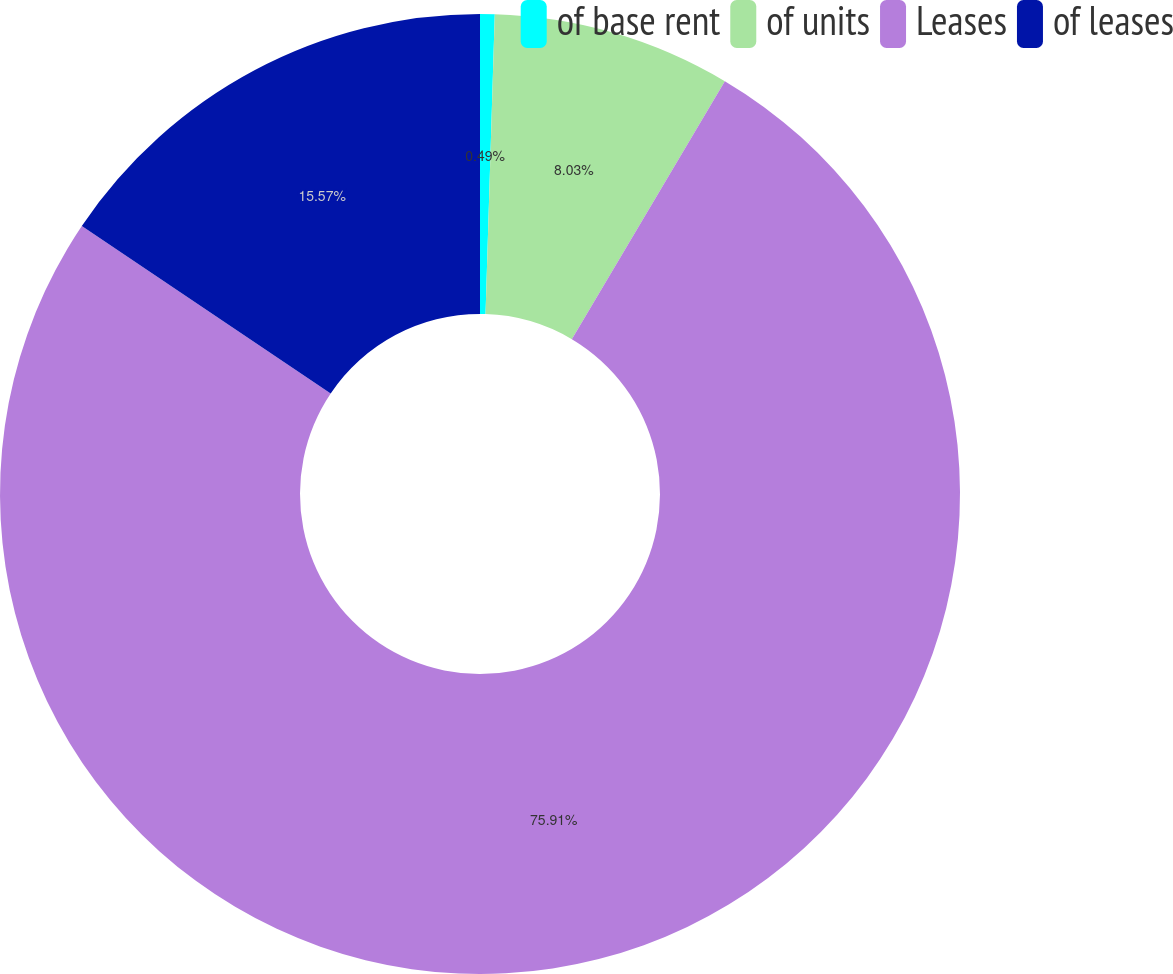Convert chart to OTSL. <chart><loc_0><loc_0><loc_500><loc_500><pie_chart><fcel>of base rent<fcel>of units<fcel>Leases<fcel>of leases<nl><fcel>0.49%<fcel>8.03%<fcel>75.91%<fcel>15.57%<nl></chart> 